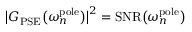Convert formula to latex. <formula><loc_0><loc_0><loc_500><loc_500>\left | G _ { P S E } \left ( \omega _ { n } ^ { p o l e } \right ) \right | ^ { 2 } = S N R \left ( \omega _ { n } ^ { p o l e } \right )</formula> 